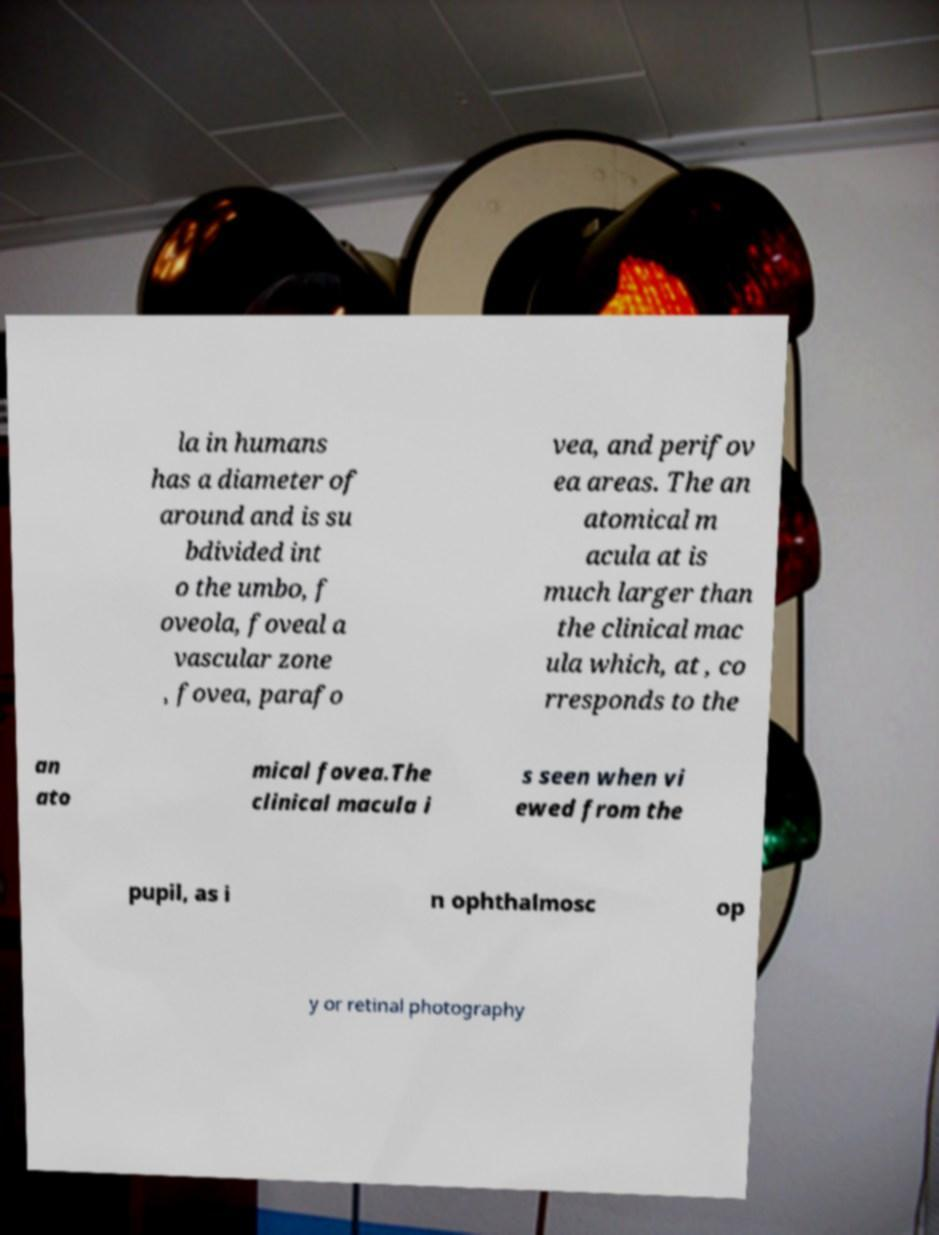Could you assist in decoding the text presented in this image and type it out clearly? la in humans has a diameter of around and is su bdivided int o the umbo, f oveola, foveal a vascular zone , fovea, parafo vea, and perifov ea areas. The an atomical m acula at is much larger than the clinical mac ula which, at , co rresponds to the an ato mical fovea.The clinical macula i s seen when vi ewed from the pupil, as i n ophthalmosc op y or retinal photography 